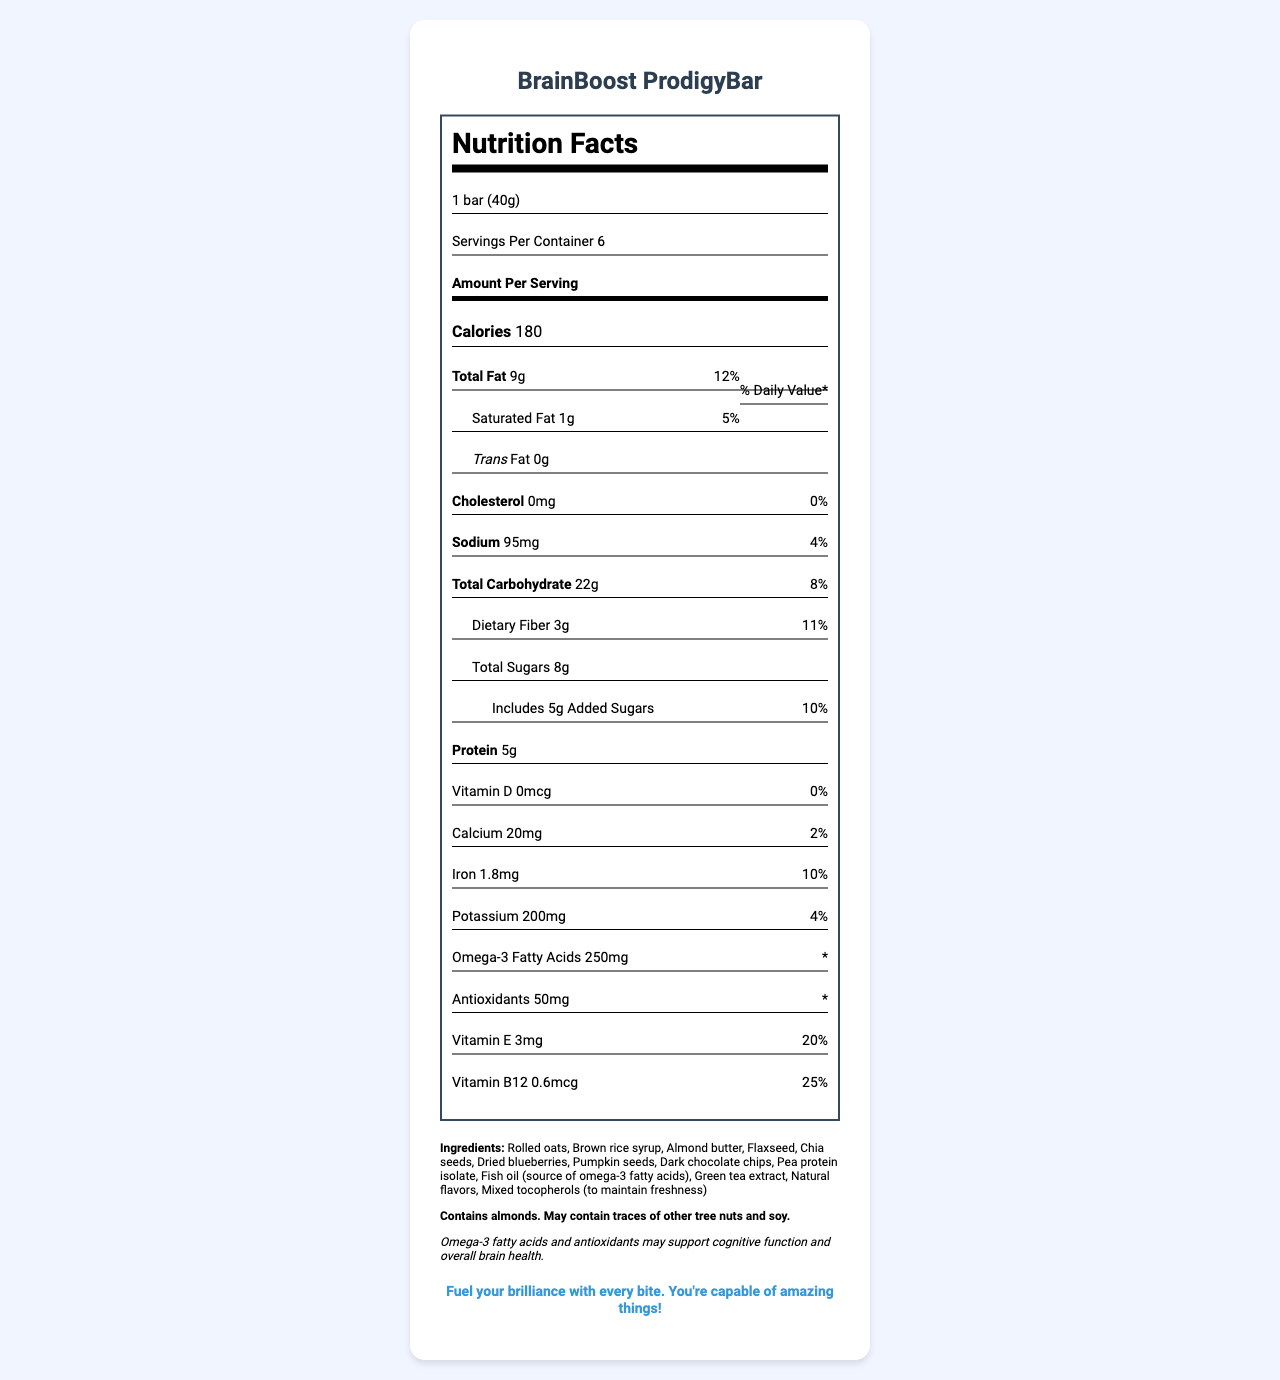what is the serving size? The serving size is explicitly stated under the "Nutrition Facts" heading.
Answer: 1 bar (40g) how many servings are in one container? The number of servings per container is listed right below the serving size.
Answer: 6 how many calories are in one bar? The calorie content per serving is clearly marked under the "Amount Per Serving" section.
Answer: 180 how much protein does the BrainBoost ProdigyBar have? The protein content is listed under the "Amount Per Serving" section.
Answer: 5g what is the percentage daily value of saturated fat? The daily value percentage for saturated fat is indicated next to its amount.
Answer: 5% does this product contain any trans fat? The trans fat content is listed as 0g, indicating there is no trans fat in the product.
Answer: No how much dietary fiber is in each serving? The dietary fiber amount is specified under "Total Carbohydrate".
Answer: 3g what is the main purpose of the Omega-3 fatty acids and antioxidants in this product? This health claim is noted in the document indicating the main benefits of Omega-3 fatty acids and antioxidants.
Answer: To support cognitive function and overall brain health what are the first three ingredients listed? The ingredients are listed in the order of quantity, with the first three being rolled oats, brown rice syrup, and almond butter.
Answer: Rolled oats, Brown rice syrup, Almond butter are there any vitamins in the BrainBoost ProdigyBar? If so, which ones? The document lists Vitamin E and Vitamin B12 under the nutrition facts.
Answer: Yes, Vitamin E and Vitamin B12 how much vitamin B12 is in each serving? The amount of Vitamin B12 is listed under the nutrition facts.
Answer: 0.6mcg which of the following is an ingredient in the BrainBoost ProdigyBar? A. Sunflower oil B. Flaxseed C. Honey D. Whey Protein Flaxseed is listed among the ingredients, whereas the others are not.
Answer: B. Flaxseed how much iron is in one bar? A. 1mg B. 1.8mg C. 2.5mg D. 3mg The iron content is 1.8mg as specified under the nutrition facts.
Answer: B is there any cholesterol in this product? The cholesterol content is listed as 0mg, indicating there is no cholesterol.
Answer: No summarize the main idea of the BrainBoost ProdigyBar's nutritional benefits. The summary covers the main nutritional benefits and highlights of the product as detailed in the document.
Answer: The BrainBoost ProdigyBar is a nutritious snack designed to support cognitive function and overall brain health through its inclusion of Omega-3 fatty acids and antioxidants. It is relatively low in calories, high in dietary fiber, and contains several essential nutrients such as Vitamin E and Vitamin B12. what is the source of Omega-3 fatty acids in the BrainBoost ProdigyBar? The document lists fish oil as a source of Omega-3 fatty acids but does not specify the type or source of the fish. This requires additional information not provided in the document.
Answer: Cannot be determined 